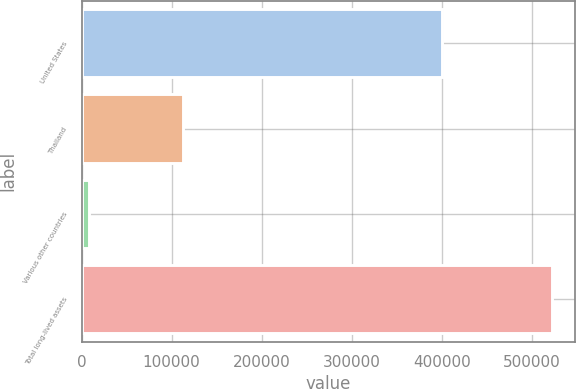Convert chart. <chart><loc_0><loc_0><loc_500><loc_500><bar_chart><fcel>United States<fcel>Thailand<fcel>Various other countries<fcel>Total long-lived assets<nl><fcel>400564<fcel>113117<fcel>8624<fcel>522305<nl></chart> 